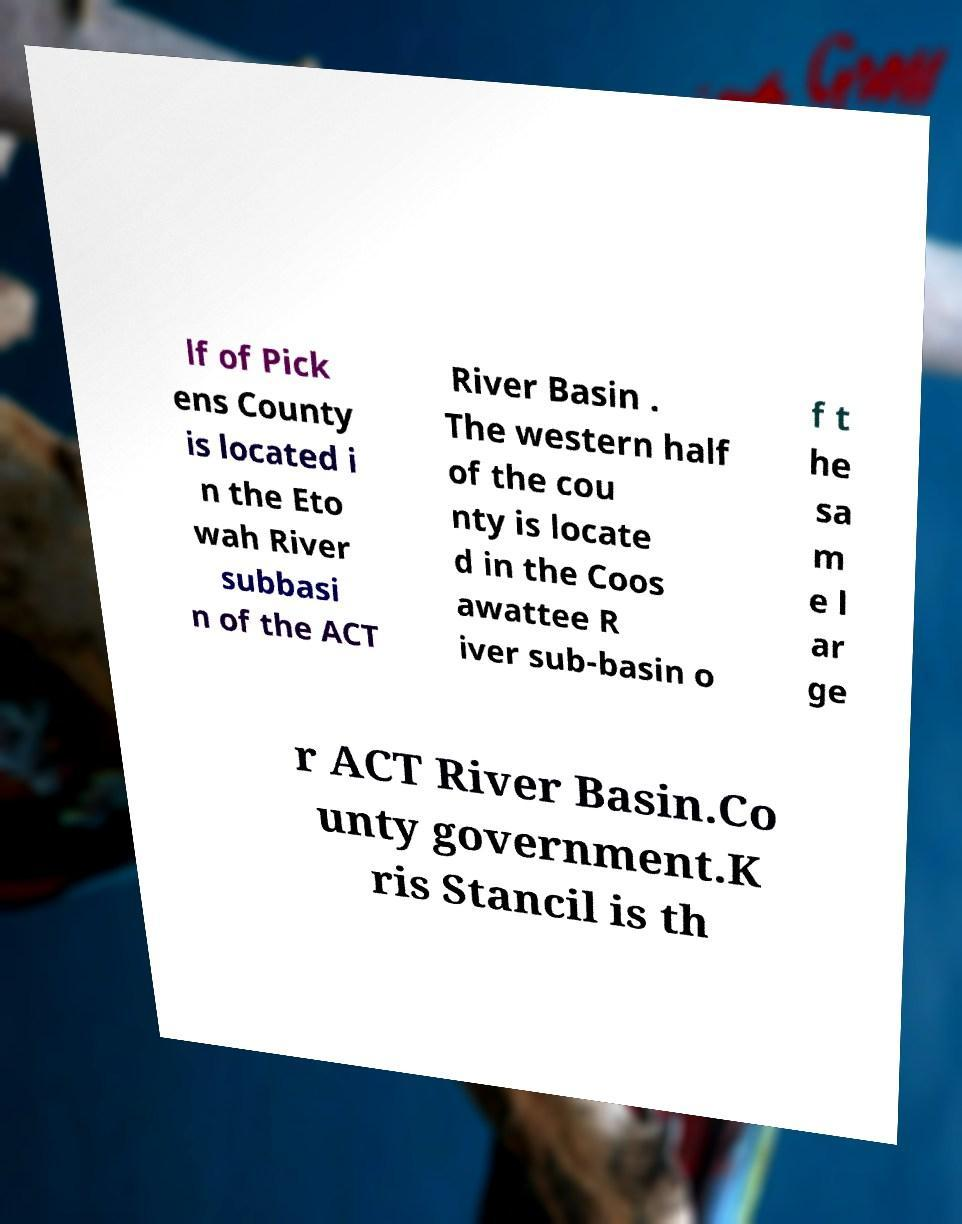There's text embedded in this image that I need extracted. Can you transcribe it verbatim? lf of Pick ens County is located i n the Eto wah River subbasi n of the ACT River Basin . The western half of the cou nty is locate d in the Coos awattee R iver sub-basin o f t he sa m e l ar ge r ACT River Basin.Co unty government.K ris Stancil is th 